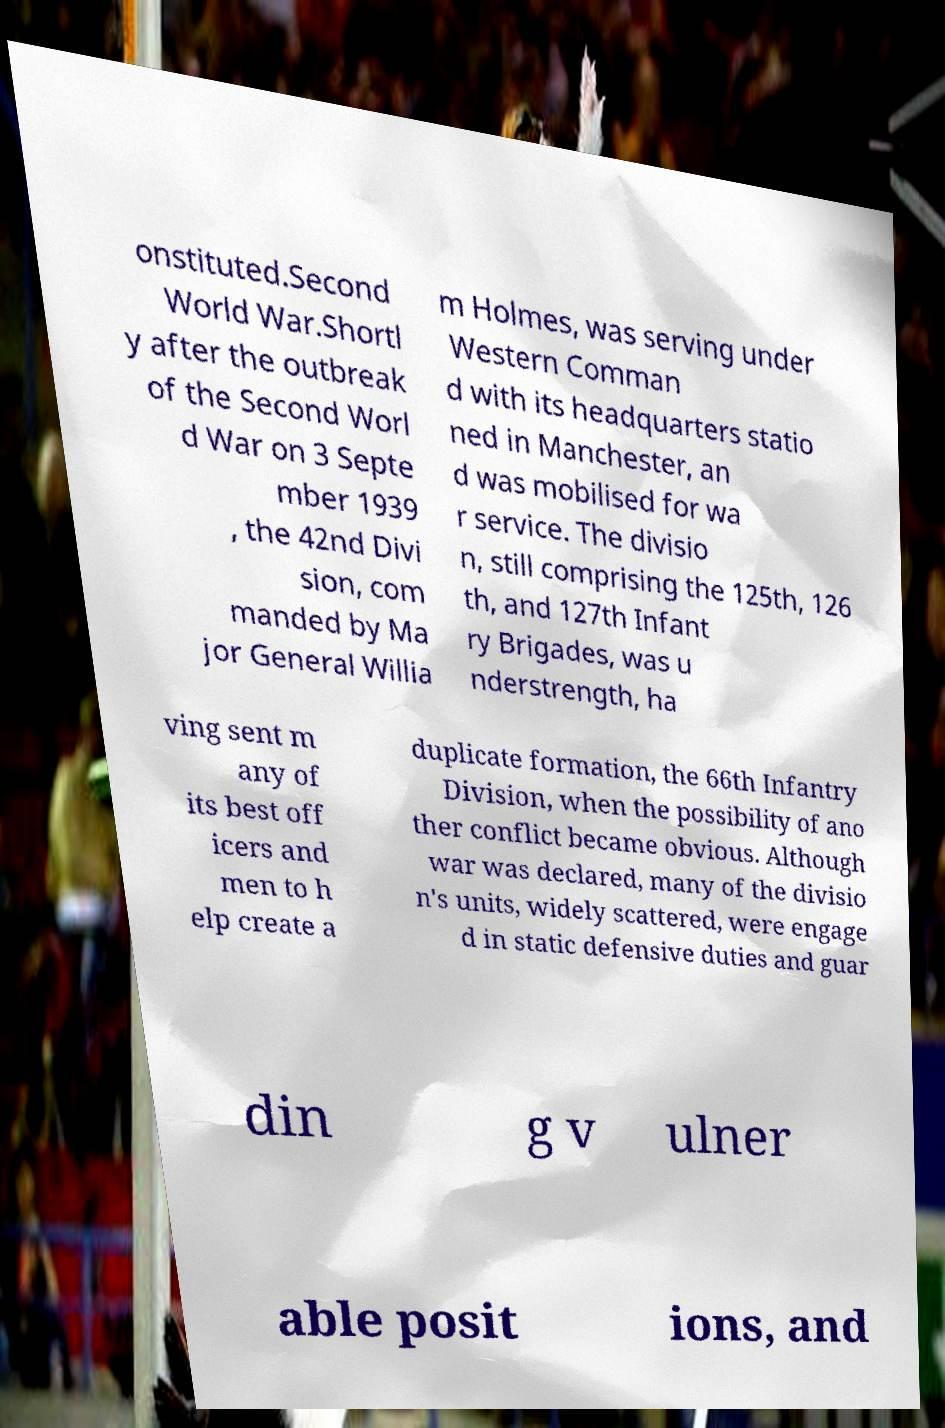Please identify and transcribe the text found in this image. onstituted.Second World War.Shortl y after the outbreak of the Second Worl d War on 3 Septe mber 1939 , the 42nd Divi sion, com manded by Ma jor General Willia m Holmes, was serving under Western Comman d with its headquarters statio ned in Manchester, an d was mobilised for wa r service. The divisio n, still comprising the 125th, 126 th, and 127th Infant ry Brigades, was u nderstrength, ha ving sent m any of its best off icers and men to h elp create a duplicate formation, the 66th Infantry Division, when the possibility of ano ther conflict became obvious. Although war was declared, many of the divisio n's units, widely scattered, were engage d in static defensive duties and guar din g v ulner able posit ions, and 